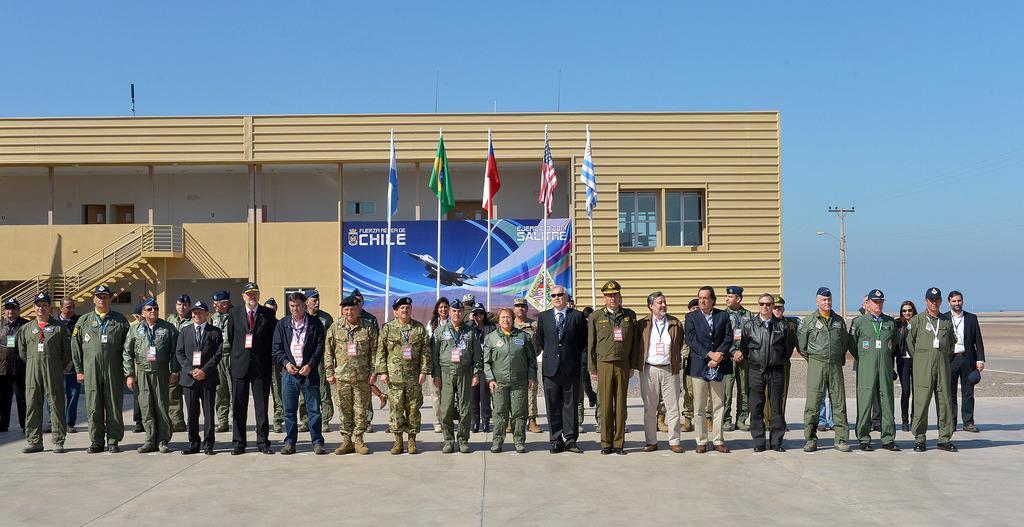Can you describe this image briefly? In this picture we can see many people standing on the ground in front of flags and a building with an air force board on it. The sky is blue. In the background, we can see an electric light pole on the ground. 